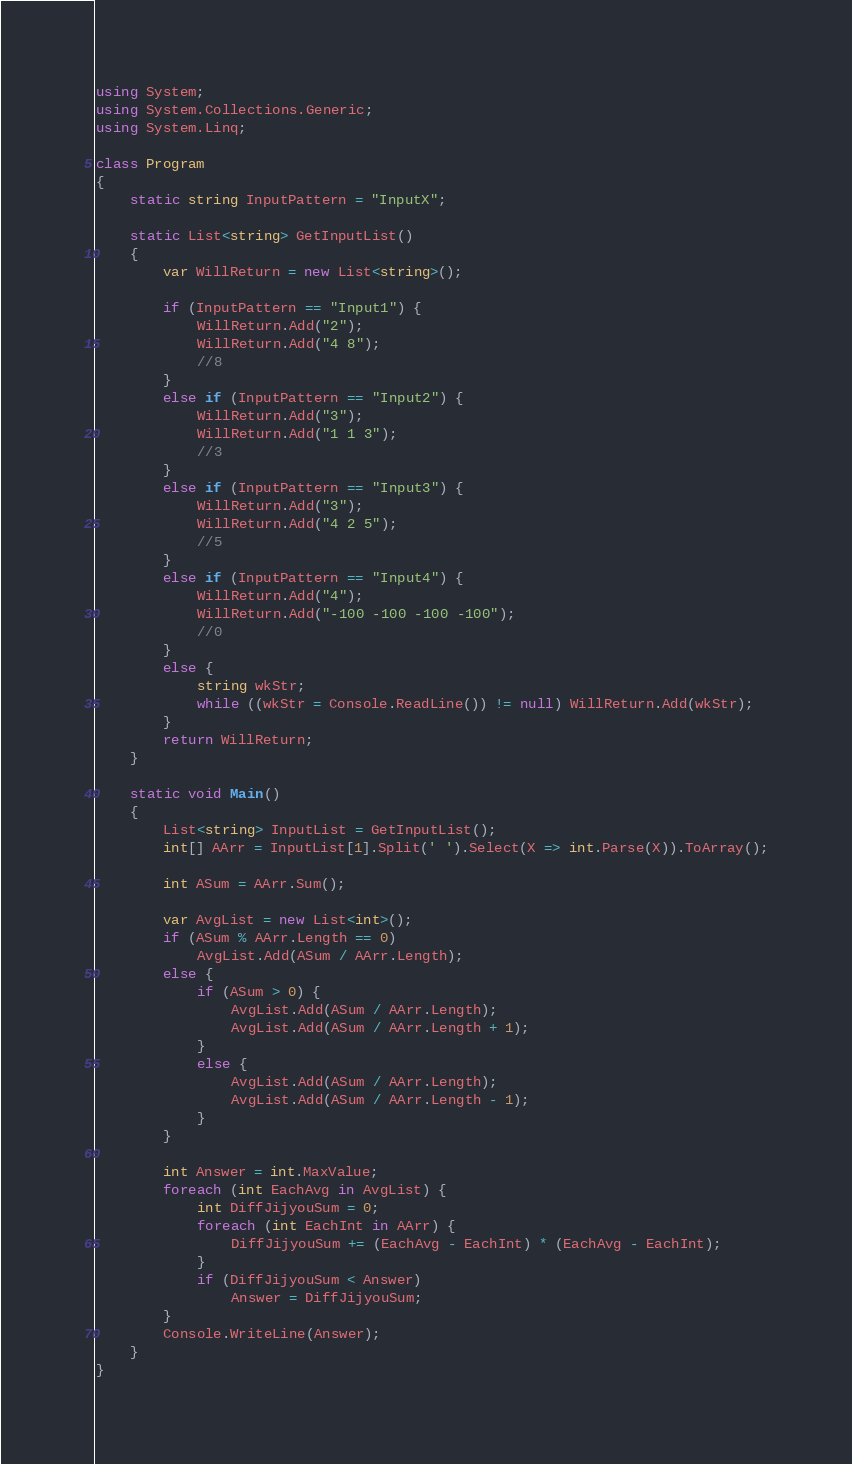Convert code to text. <code><loc_0><loc_0><loc_500><loc_500><_C#_>using System;
using System.Collections.Generic;
using System.Linq;

class Program
{
    static string InputPattern = "InputX";

    static List<string> GetInputList()
    {
        var WillReturn = new List<string>();

        if (InputPattern == "Input1") {
            WillReturn.Add("2");
            WillReturn.Add("4 8");
            //8
        }
        else if (InputPattern == "Input2") {
            WillReturn.Add("3");
            WillReturn.Add("1 1 3");
            //3
        }
        else if (InputPattern == "Input3") {
            WillReturn.Add("3");
            WillReturn.Add("4 2 5");
            //5
        }
        else if (InputPattern == "Input4") {
            WillReturn.Add("4");
            WillReturn.Add("-100 -100 -100 -100");
            //0
        }
        else {
            string wkStr;
            while ((wkStr = Console.ReadLine()) != null) WillReturn.Add(wkStr);
        }
        return WillReturn;
    }

    static void Main()
    {
        List<string> InputList = GetInputList();
        int[] AArr = InputList[1].Split(' ').Select(X => int.Parse(X)).ToArray();

        int ASum = AArr.Sum();

        var AvgList = new List<int>();
        if (ASum % AArr.Length == 0)
            AvgList.Add(ASum / AArr.Length);
        else {
            if (ASum > 0) {
                AvgList.Add(ASum / AArr.Length);
                AvgList.Add(ASum / AArr.Length + 1);
            }
            else {
                AvgList.Add(ASum / AArr.Length);
                AvgList.Add(ASum / AArr.Length - 1);
            }
        }

        int Answer = int.MaxValue;
        foreach (int EachAvg in AvgList) {
            int DiffJijyouSum = 0;
            foreach (int EachInt in AArr) {
                DiffJijyouSum += (EachAvg - EachInt) * (EachAvg - EachInt);
            }
            if (DiffJijyouSum < Answer)
                Answer = DiffJijyouSum;
        }
        Console.WriteLine(Answer);
    }
}
</code> 